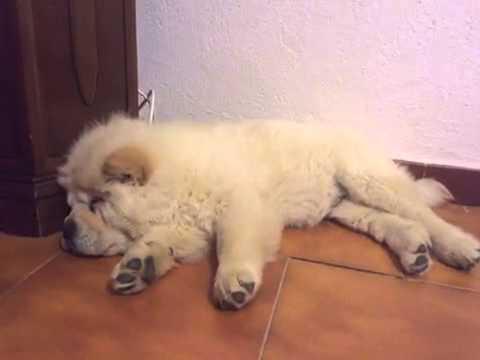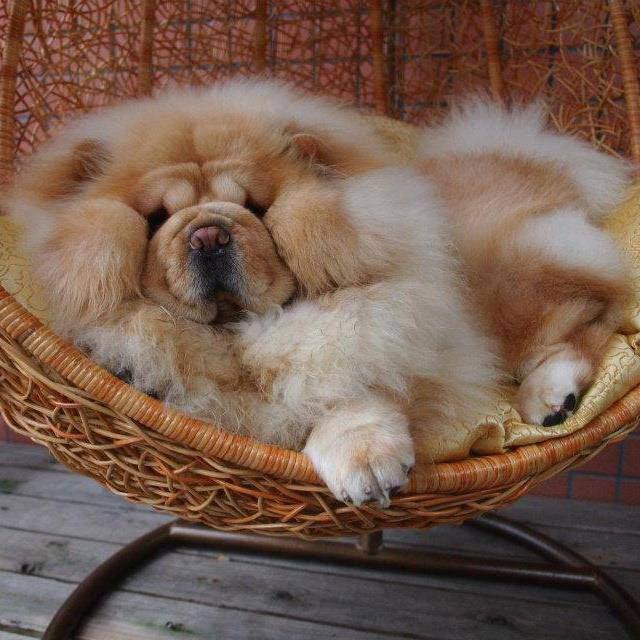The first image is the image on the left, the second image is the image on the right. For the images shown, is this caption "The dog in the image on the left is sleeping on the tiled surface." true? Answer yes or no. Yes. The first image is the image on the left, the second image is the image on the right. Analyze the images presented: Is the assertion "An image shows a chow dog sleeping up off the ground, on some type of seat." valid? Answer yes or no. Yes. 